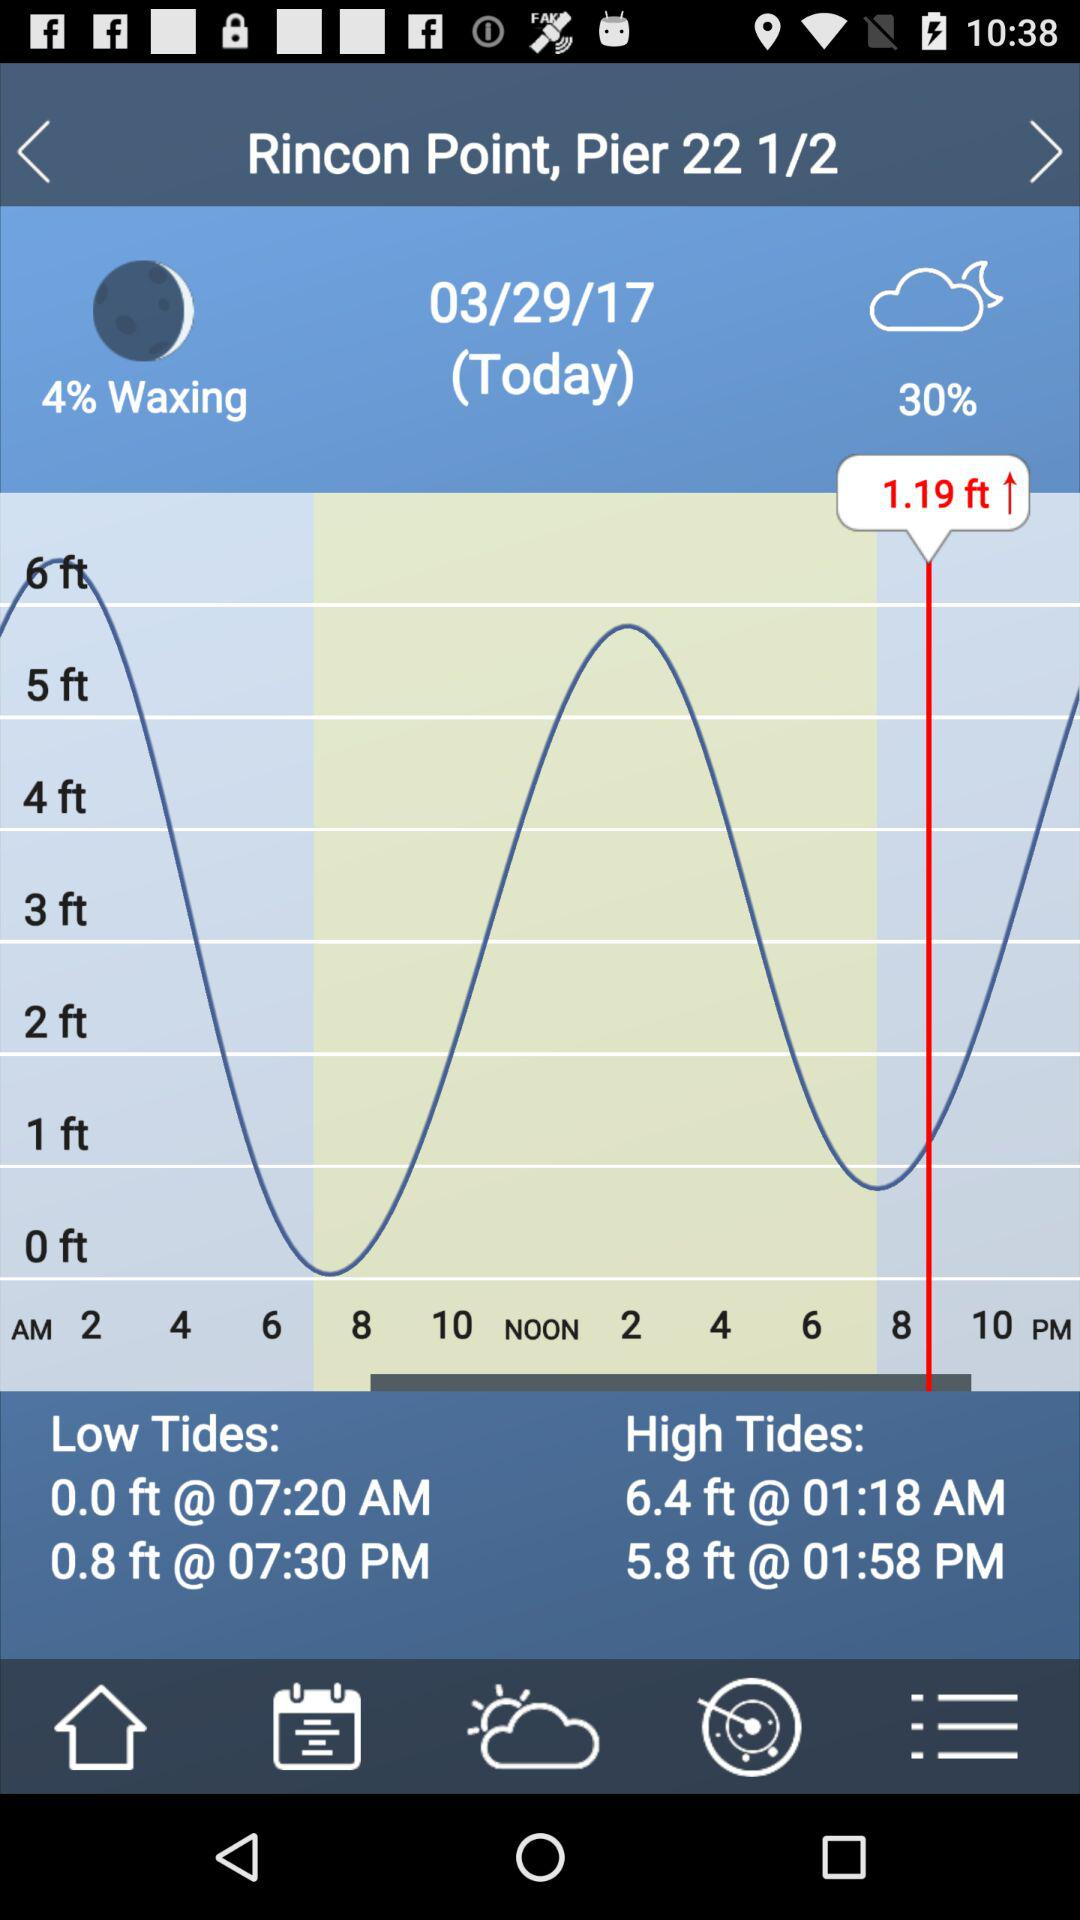What is the time of the high tides? The times of the high tides are 01:18 AM and 01:58 PM. 